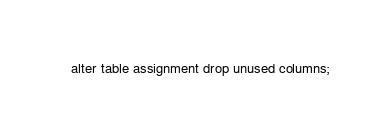<code> <loc_0><loc_0><loc_500><loc_500><_SQL_>alter table assignment drop unused columns;</code> 